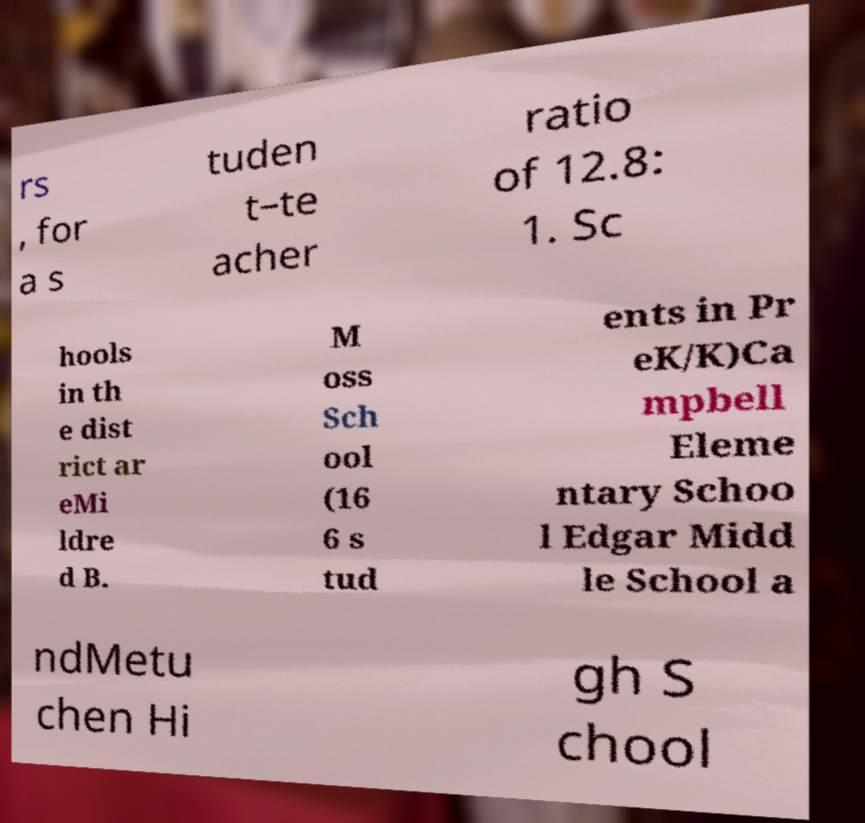I need the written content from this picture converted into text. Can you do that? rs , for a s tuden t–te acher ratio of 12.8: 1. Sc hools in th e dist rict ar eMi ldre d B. M oss Sch ool (16 6 s tud ents in Pr eK/K)Ca mpbell Eleme ntary Schoo l Edgar Midd le School a ndMetu chen Hi gh S chool 